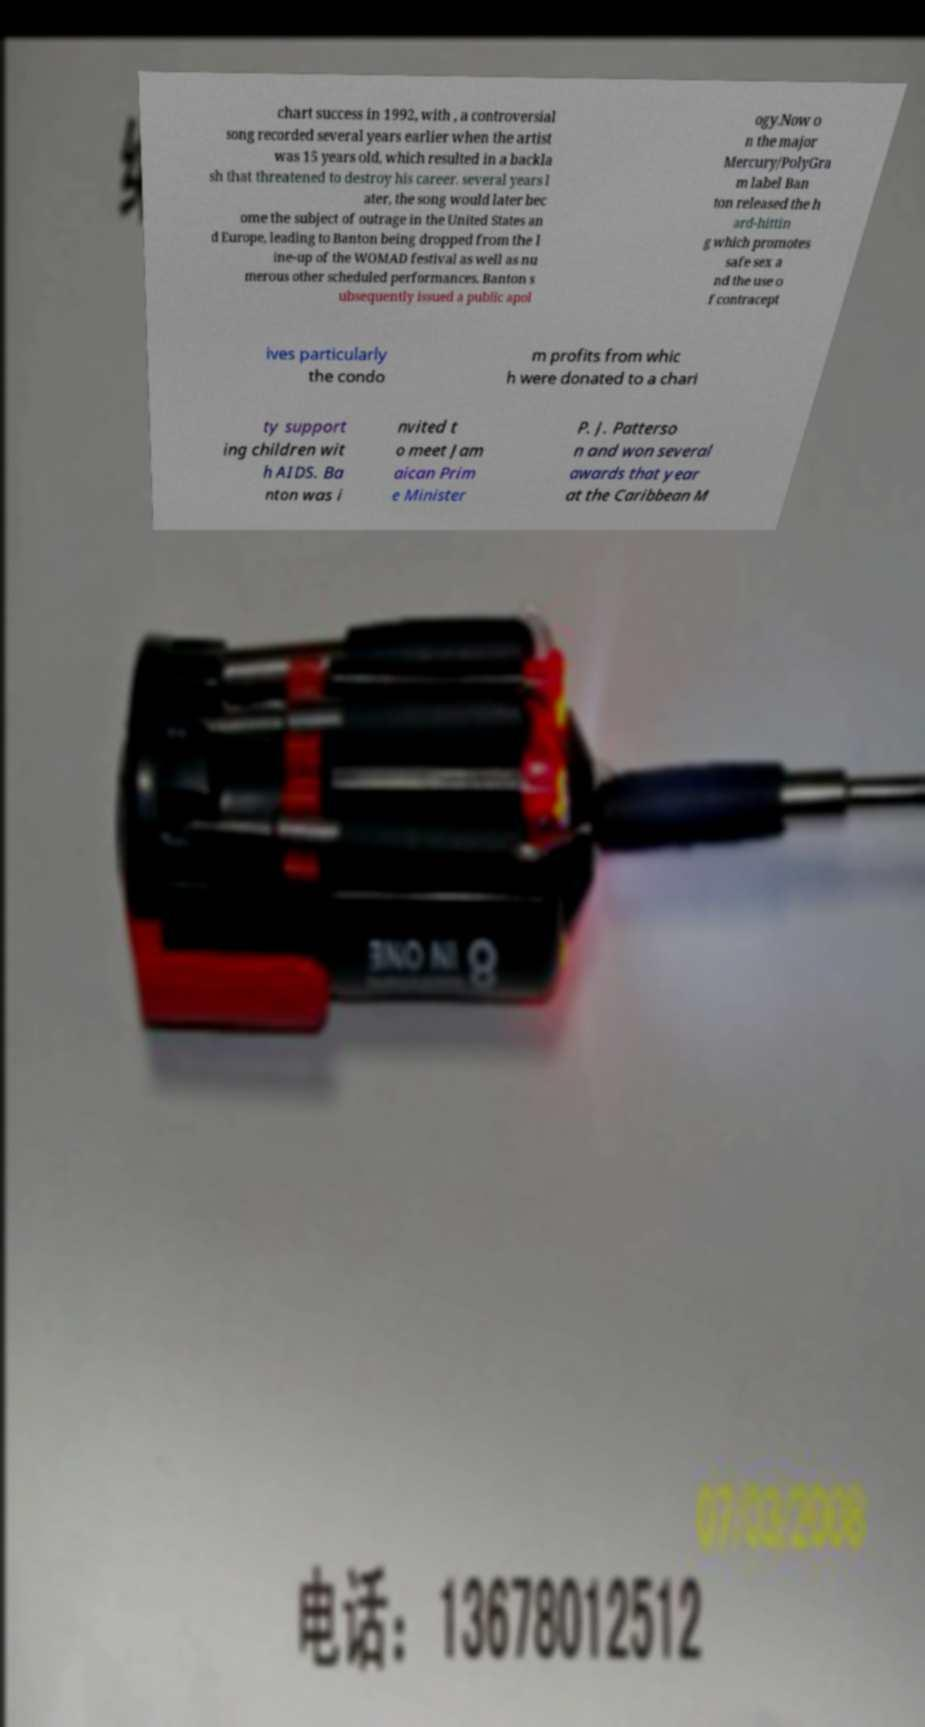For documentation purposes, I need the text within this image transcribed. Could you provide that? chart success in 1992, with , a controversial song recorded several years earlier when the artist was 15 years old, which resulted in a backla sh that threatened to destroy his career. several years l ater, the song would later bec ome the subject of outrage in the United States an d Europe, leading to Banton being dropped from the l ine-up of the WOMAD festival as well as nu merous other scheduled performances. Banton s ubsequently issued a public apol ogy.Now o n the major Mercury/PolyGra m label Ban ton released the h ard-hittin g which promotes safe sex a nd the use o f contracept ives particularly the condo m profits from whic h were donated to a chari ty support ing children wit h AIDS. Ba nton was i nvited t o meet Jam aican Prim e Minister P. J. Patterso n and won several awards that year at the Caribbean M 